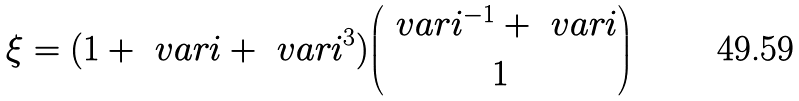<formula> <loc_0><loc_0><loc_500><loc_500>\xi = ( 1 + \ v a r i + \ v a r i ^ { 3 } ) { \ v a r i ^ { - 1 } + \ v a r i \choose 1 }</formula> 